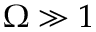Convert formula to latex. <formula><loc_0><loc_0><loc_500><loc_500>\Omega \gg 1</formula> 